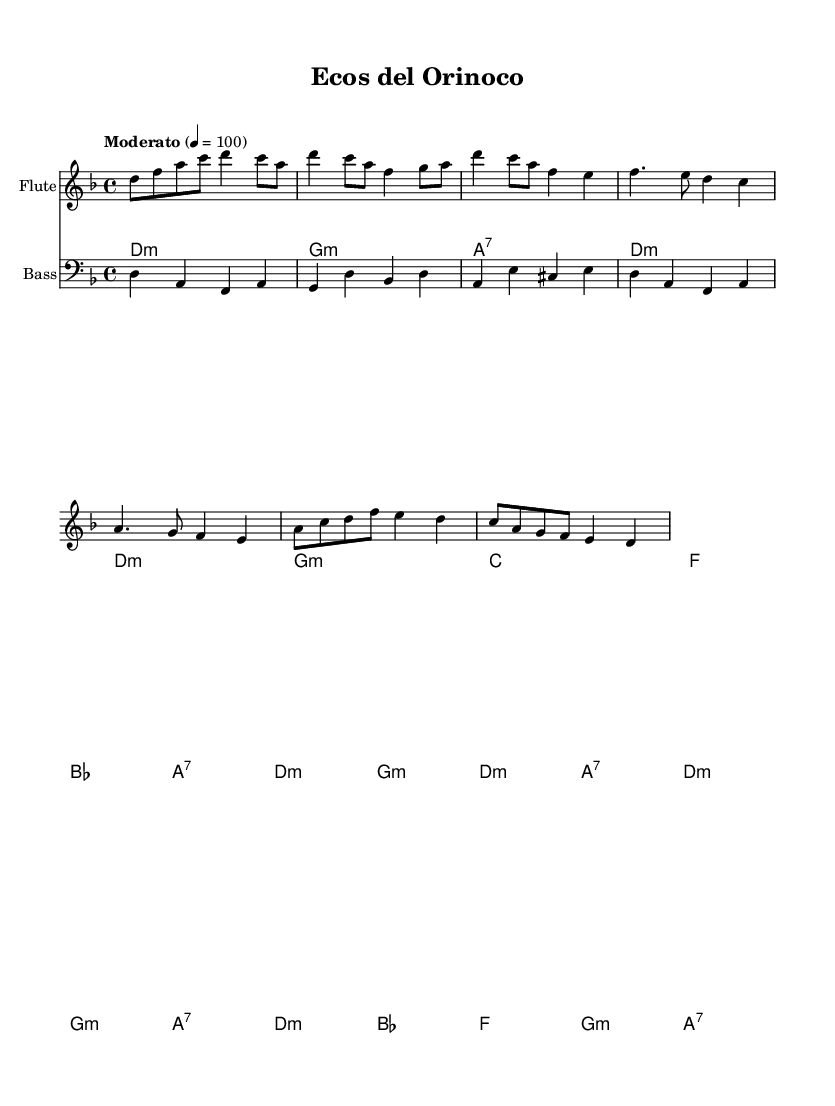What is the key signature of this music? The key signature indicated in the music sheet is D minor, which has one flat (B flat). This can be determined by looking at the key signature marking at the beginning of the score, which usually appears right after the clef symbol.
Answer: D minor What is the time signature used in this piece? The time signature is located at the beginning of the score, after the key signature, and shows that there are four beats in each measure with a quarter note getting one beat. This is denoted by the notation 4/4.
Answer: 4/4 What is the tempo marking given for this piece? The tempo indication at the start of the score states "Moderato" with a metronome marking of 4 = 100. This implies that the piece should be played moderately fast, specifically 100 beats per minute.
Answer: Moderato How many measures are in the flute part? By counting the individual groupings delineated by the vertical lines (bar lines) within the flute staff, we find the total number of measures. In this score, there are 16 measures in total.
Answer: 16 What type of musical ensemble is indicated in the score? The score features three distinct instruments: flute, cuatro, and bass, which highlights a typical instrumentation commonly used in contemporary Latin American fusion music, particularly Venezuelan styles. This can be seen from the instrument names written at the start of each staff.
Answer: Flute, Cuatro, Bass Which chord appears most frequently in the cuatro part? By examining the chord notation in the cuatro staff, we can count the occurrences of each chord. The D minor chord appears frequently in the chord progression throughout the cuatro part, dominating several measures.
Answer: D minor What is a characteristic feature of the bass part in this piece? The bass part showcases a rhythmic pattern that is syncopated and complements the harmonic structure provided by the cuatro, creating a rich, layered musical texture. Observing the note durations and placements reveals this characteristic.
Answer: Syncopated 